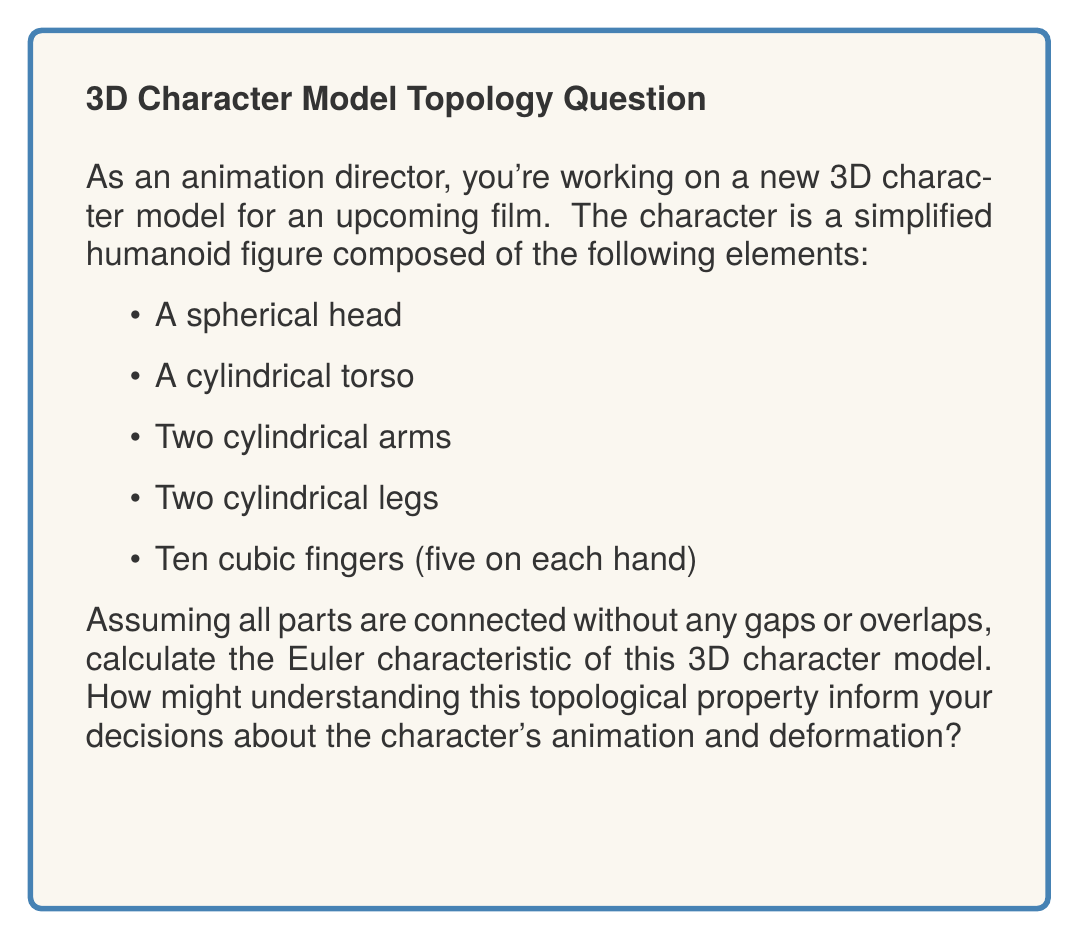Help me with this question. To calculate the Euler characteristic of the 3D character model, we need to use the formula:

$$\chi = V - E + F$$

Where:
$\chi$ is the Euler characteristic
$V$ is the number of vertices
$E$ is the number of edges
$F$ is the number of faces

Let's break down each component:

1. Spherical head: $\chi_{sphere} = 2$
2. Cylindrical torso: $\chi_{cylinder} = 0$
3. Two cylindrical arms: $\chi_{cylinder} \times 2 = 0$
4. Two cylindrical legs: $\chi_{cylinder} \times 2 = 0$
5. Ten cubic fingers: $\chi_{cube} \times 10 = 2 \times 10 = 20$

Now, we need to account for the connections between these parts:
- Head-torso connection: $-1$
- Two arm-torso connections: $-2$
- Two leg-torso connections: $-2$
- Ten finger-hand connections: $-10$

The total Euler characteristic is the sum of all components minus the connections:

$$\chi_{total} = 2 + 0 + 0 + 0 + 20 - 1 - 2 - 2 - 10 = 7$$

Understanding this topological property can inform animation decisions by:
1. Helping predict how the model will deform under different transformations
2. Identifying potential issues with mesh topology that could affect smooth animations
3. Guiding the placement of control points for rigging and skinning
4. Assisting in optimizing the model for real-time rendering in animation software
Answer: $\chi = 7$ 